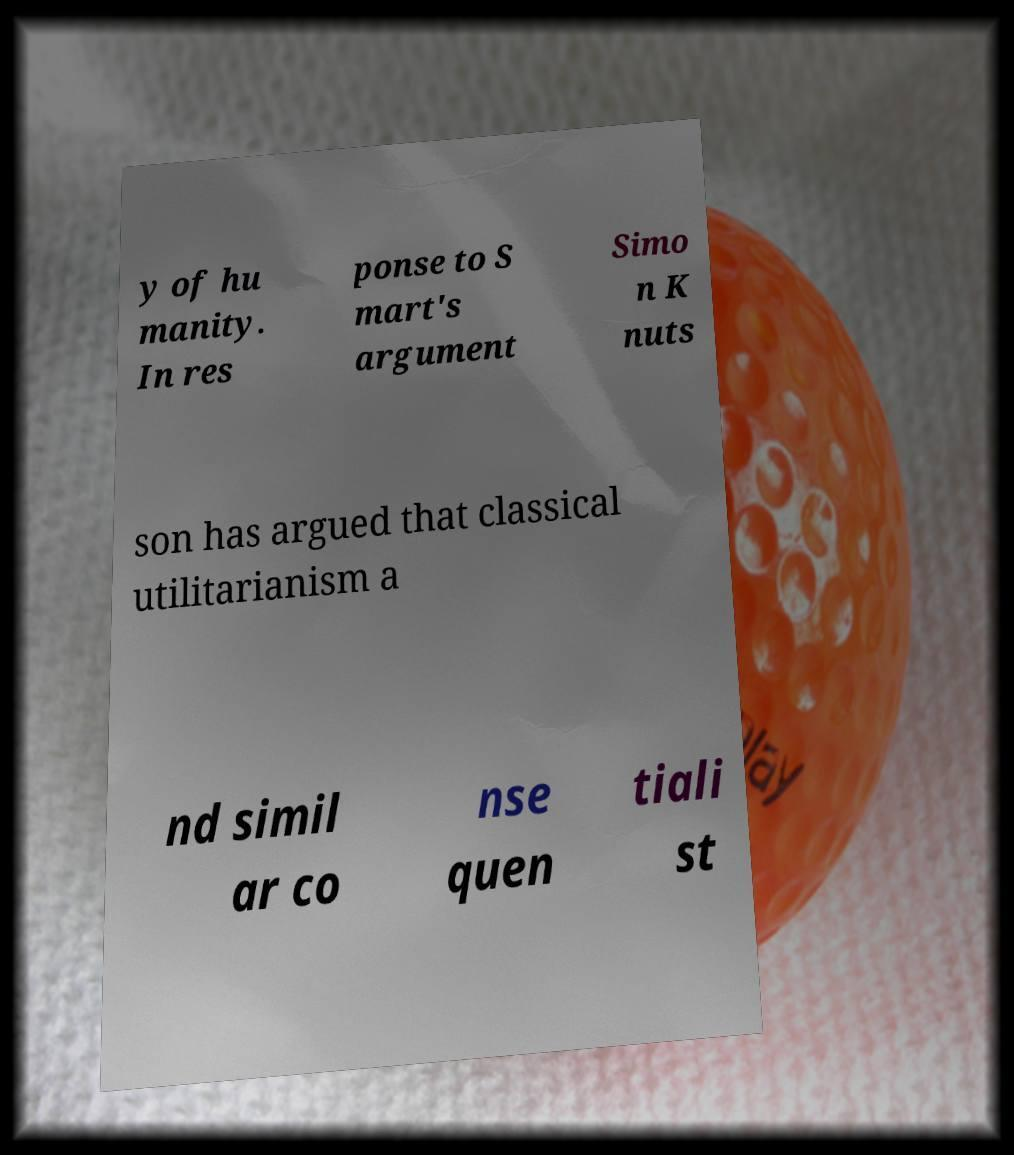Could you assist in decoding the text presented in this image and type it out clearly? y of hu manity. In res ponse to S mart's argument Simo n K nuts son has argued that classical utilitarianism a nd simil ar co nse quen tiali st 